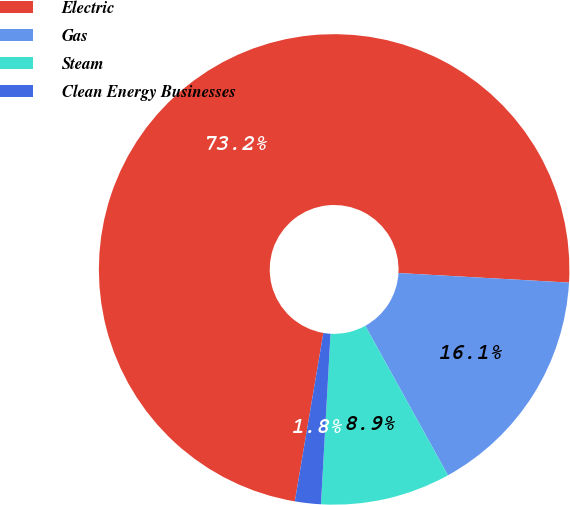<chart> <loc_0><loc_0><loc_500><loc_500><pie_chart><fcel>Electric<fcel>Gas<fcel>Steam<fcel>Clean Energy Businesses<nl><fcel>73.22%<fcel>16.07%<fcel>8.93%<fcel>1.78%<nl></chart> 